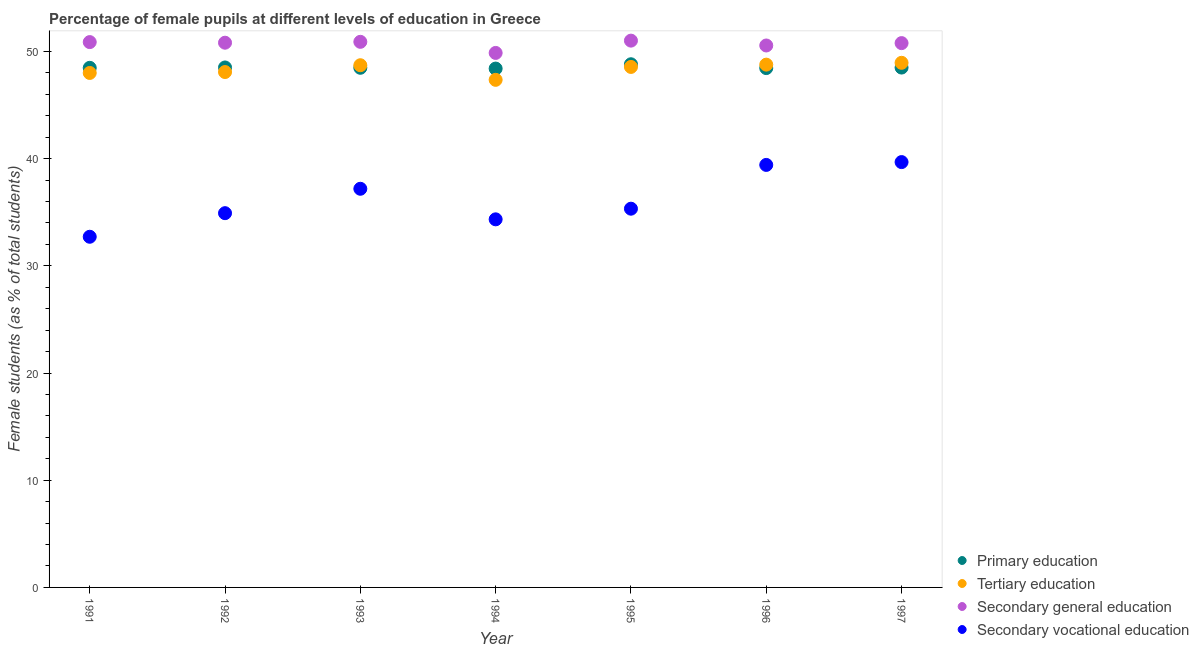Is the number of dotlines equal to the number of legend labels?
Provide a succinct answer. Yes. What is the percentage of female students in tertiary education in 1996?
Your response must be concise. 48.77. Across all years, what is the maximum percentage of female students in secondary vocational education?
Your answer should be very brief. 39.68. Across all years, what is the minimum percentage of female students in primary education?
Your response must be concise. 48.4. In which year was the percentage of female students in secondary education minimum?
Make the answer very short. 1994. What is the total percentage of female students in secondary education in the graph?
Offer a terse response. 354.77. What is the difference between the percentage of female students in secondary vocational education in 1996 and that in 1997?
Provide a succinct answer. -0.26. What is the difference between the percentage of female students in secondary vocational education in 1993 and the percentage of female students in secondary education in 1995?
Your answer should be very brief. -13.82. What is the average percentage of female students in primary education per year?
Keep it short and to the point. 48.51. In the year 1993, what is the difference between the percentage of female students in primary education and percentage of female students in secondary education?
Your answer should be very brief. -2.42. What is the ratio of the percentage of female students in tertiary education in 1995 to that in 1997?
Keep it short and to the point. 0.99. What is the difference between the highest and the second highest percentage of female students in secondary vocational education?
Your answer should be very brief. 0.26. What is the difference between the highest and the lowest percentage of female students in secondary education?
Offer a terse response. 1.15. Is the sum of the percentage of female students in tertiary education in 1992 and 1997 greater than the maximum percentage of female students in secondary vocational education across all years?
Ensure brevity in your answer.  Yes. Is it the case that in every year, the sum of the percentage of female students in primary education and percentage of female students in tertiary education is greater than the percentage of female students in secondary education?
Provide a succinct answer. Yes. Is the percentage of female students in primary education strictly greater than the percentage of female students in secondary vocational education over the years?
Keep it short and to the point. Yes. How many dotlines are there?
Your answer should be compact. 4. Are the values on the major ticks of Y-axis written in scientific E-notation?
Provide a short and direct response. No. Does the graph contain any zero values?
Offer a very short reply. No. Where does the legend appear in the graph?
Provide a succinct answer. Bottom right. How many legend labels are there?
Your answer should be very brief. 4. How are the legend labels stacked?
Ensure brevity in your answer.  Vertical. What is the title of the graph?
Keep it short and to the point. Percentage of female pupils at different levels of education in Greece. What is the label or title of the Y-axis?
Provide a short and direct response. Female students (as % of total students). What is the Female students (as % of total students) in Primary education in 1991?
Offer a very short reply. 48.47. What is the Female students (as % of total students) of Tertiary education in 1991?
Ensure brevity in your answer.  47.99. What is the Female students (as % of total students) of Secondary general education in 1991?
Your answer should be very brief. 50.87. What is the Female students (as % of total students) of Secondary vocational education in 1991?
Make the answer very short. 32.71. What is the Female students (as % of total students) in Primary education in 1992?
Offer a terse response. 48.5. What is the Female students (as % of total students) in Tertiary education in 1992?
Ensure brevity in your answer.  48.08. What is the Female students (as % of total students) in Secondary general education in 1992?
Your answer should be compact. 50.81. What is the Female students (as % of total students) in Secondary vocational education in 1992?
Give a very brief answer. 34.91. What is the Female students (as % of total students) of Primary education in 1993?
Your answer should be very brief. 48.47. What is the Female students (as % of total students) of Tertiary education in 1993?
Offer a terse response. 48.71. What is the Female students (as % of total students) of Secondary general education in 1993?
Give a very brief answer. 50.9. What is the Female students (as % of total students) of Secondary vocational education in 1993?
Offer a very short reply. 37.19. What is the Female students (as % of total students) in Primary education in 1994?
Offer a very short reply. 48.4. What is the Female students (as % of total students) of Tertiary education in 1994?
Your answer should be compact. 47.35. What is the Female students (as % of total students) of Secondary general education in 1994?
Offer a terse response. 49.86. What is the Female students (as % of total students) in Secondary vocational education in 1994?
Make the answer very short. 34.34. What is the Female students (as % of total students) of Primary education in 1995?
Give a very brief answer. 48.8. What is the Female students (as % of total students) in Tertiary education in 1995?
Your response must be concise. 48.55. What is the Female students (as % of total students) of Secondary general education in 1995?
Your answer should be very brief. 51.01. What is the Female students (as % of total students) in Secondary vocational education in 1995?
Make the answer very short. 35.33. What is the Female students (as % of total students) in Primary education in 1996?
Ensure brevity in your answer.  48.45. What is the Female students (as % of total students) of Tertiary education in 1996?
Offer a very short reply. 48.77. What is the Female students (as % of total students) in Secondary general education in 1996?
Ensure brevity in your answer.  50.55. What is the Female students (as % of total students) of Secondary vocational education in 1996?
Ensure brevity in your answer.  39.41. What is the Female students (as % of total students) in Primary education in 1997?
Your answer should be compact. 48.49. What is the Female students (as % of total students) of Tertiary education in 1997?
Keep it short and to the point. 48.94. What is the Female students (as % of total students) of Secondary general education in 1997?
Your response must be concise. 50.78. What is the Female students (as % of total students) of Secondary vocational education in 1997?
Provide a succinct answer. 39.68. Across all years, what is the maximum Female students (as % of total students) of Primary education?
Give a very brief answer. 48.8. Across all years, what is the maximum Female students (as % of total students) in Tertiary education?
Provide a short and direct response. 48.94. Across all years, what is the maximum Female students (as % of total students) in Secondary general education?
Offer a very short reply. 51.01. Across all years, what is the maximum Female students (as % of total students) of Secondary vocational education?
Offer a terse response. 39.68. Across all years, what is the minimum Female students (as % of total students) in Primary education?
Provide a short and direct response. 48.4. Across all years, what is the minimum Female students (as % of total students) of Tertiary education?
Provide a short and direct response. 47.35. Across all years, what is the minimum Female students (as % of total students) in Secondary general education?
Your response must be concise. 49.86. Across all years, what is the minimum Female students (as % of total students) of Secondary vocational education?
Offer a very short reply. 32.71. What is the total Female students (as % of total students) of Primary education in the graph?
Make the answer very short. 339.59. What is the total Female students (as % of total students) in Tertiary education in the graph?
Your answer should be very brief. 338.39. What is the total Female students (as % of total students) in Secondary general education in the graph?
Provide a succinct answer. 354.77. What is the total Female students (as % of total students) of Secondary vocational education in the graph?
Provide a succinct answer. 253.56. What is the difference between the Female students (as % of total students) of Primary education in 1991 and that in 1992?
Give a very brief answer. -0.03. What is the difference between the Female students (as % of total students) of Tertiary education in 1991 and that in 1992?
Provide a short and direct response. -0.09. What is the difference between the Female students (as % of total students) in Secondary general education in 1991 and that in 1992?
Offer a terse response. 0.06. What is the difference between the Female students (as % of total students) of Secondary vocational education in 1991 and that in 1992?
Your response must be concise. -2.2. What is the difference between the Female students (as % of total students) of Primary education in 1991 and that in 1993?
Give a very brief answer. -0. What is the difference between the Female students (as % of total students) in Tertiary education in 1991 and that in 1993?
Provide a succinct answer. -0.72. What is the difference between the Female students (as % of total students) in Secondary general education in 1991 and that in 1993?
Provide a short and direct response. -0.03. What is the difference between the Female students (as % of total students) in Secondary vocational education in 1991 and that in 1993?
Offer a terse response. -4.48. What is the difference between the Female students (as % of total students) in Primary education in 1991 and that in 1994?
Keep it short and to the point. 0.07. What is the difference between the Female students (as % of total students) in Tertiary education in 1991 and that in 1994?
Provide a succinct answer. 0.64. What is the difference between the Female students (as % of total students) in Secondary general education in 1991 and that in 1994?
Your answer should be compact. 1.01. What is the difference between the Female students (as % of total students) in Secondary vocational education in 1991 and that in 1994?
Keep it short and to the point. -1.63. What is the difference between the Female students (as % of total students) in Primary education in 1991 and that in 1995?
Offer a very short reply. -0.33. What is the difference between the Female students (as % of total students) of Tertiary education in 1991 and that in 1995?
Your answer should be very brief. -0.56. What is the difference between the Female students (as % of total students) of Secondary general education in 1991 and that in 1995?
Keep it short and to the point. -0.14. What is the difference between the Female students (as % of total students) in Secondary vocational education in 1991 and that in 1995?
Offer a terse response. -2.62. What is the difference between the Female students (as % of total students) of Primary education in 1991 and that in 1996?
Make the answer very short. 0.02. What is the difference between the Female students (as % of total students) of Tertiary education in 1991 and that in 1996?
Keep it short and to the point. -0.78. What is the difference between the Female students (as % of total students) in Secondary general education in 1991 and that in 1996?
Ensure brevity in your answer.  0.32. What is the difference between the Female students (as % of total students) in Secondary vocational education in 1991 and that in 1996?
Ensure brevity in your answer.  -6.7. What is the difference between the Female students (as % of total students) in Primary education in 1991 and that in 1997?
Offer a very short reply. -0.02. What is the difference between the Female students (as % of total students) in Tertiary education in 1991 and that in 1997?
Keep it short and to the point. -0.95. What is the difference between the Female students (as % of total students) in Secondary general education in 1991 and that in 1997?
Make the answer very short. 0.1. What is the difference between the Female students (as % of total students) in Secondary vocational education in 1991 and that in 1997?
Offer a terse response. -6.97. What is the difference between the Female students (as % of total students) of Primary education in 1992 and that in 1993?
Give a very brief answer. 0.03. What is the difference between the Female students (as % of total students) in Tertiary education in 1992 and that in 1993?
Provide a succinct answer. -0.64. What is the difference between the Female students (as % of total students) of Secondary general education in 1992 and that in 1993?
Provide a short and direct response. -0.08. What is the difference between the Female students (as % of total students) of Secondary vocational education in 1992 and that in 1993?
Your response must be concise. -2.28. What is the difference between the Female students (as % of total students) of Primary education in 1992 and that in 1994?
Your answer should be compact. 0.1. What is the difference between the Female students (as % of total students) of Tertiary education in 1992 and that in 1994?
Offer a very short reply. 0.73. What is the difference between the Female students (as % of total students) in Secondary general education in 1992 and that in 1994?
Give a very brief answer. 0.95. What is the difference between the Female students (as % of total students) in Secondary vocational education in 1992 and that in 1994?
Make the answer very short. 0.58. What is the difference between the Female students (as % of total students) in Primary education in 1992 and that in 1995?
Your answer should be compact. -0.3. What is the difference between the Female students (as % of total students) in Tertiary education in 1992 and that in 1995?
Offer a very short reply. -0.48. What is the difference between the Female students (as % of total students) in Secondary general education in 1992 and that in 1995?
Provide a short and direct response. -0.19. What is the difference between the Female students (as % of total students) in Secondary vocational education in 1992 and that in 1995?
Give a very brief answer. -0.42. What is the difference between the Female students (as % of total students) of Primary education in 1992 and that in 1996?
Provide a succinct answer. 0.06. What is the difference between the Female students (as % of total students) of Tertiary education in 1992 and that in 1996?
Your answer should be very brief. -0.69. What is the difference between the Female students (as % of total students) of Secondary general education in 1992 and that in 1996?
Your answer should be very brief. 0.26. What is the difference between the Female students (as % of total students) in Secondary vocational education in 1992 and that in 1996?
Ensure brevity in your answer.  -4.5. What is the difference between the Female students (as % of total students) in Primary education in 1992 and that in 1997?
Give a very brief answer. 0.01. What is the difference between the Female students (as % of total students) in Tertiary education in 1992 and that in 1997?
Your answer should be compact. -0.86. What is the difference between the Female students (as % of total students) in Secondary general education in 1992 and that in 1997?
Ensure brevity in your answer.  0.04. What is the difference between the Female students (as % of total students) of Secondary vocational education in 1992 and that in 1997?
Ensure brevity in your answer.  -4.76. What is the difference between the Female students (as % of total students) of Primary education in 1993 and that in 1994?
Ensure brevity in your answer.  0.07. What is the difference between the Female students (as % of total students) in Tertiary education in 1993 and that in 1994?
Give a very brief answer. 1.36. What is the difference between the Female students (as % of total students) in Secondary general education in 1993 and that in 1994?
Provide a short and direct response. 1.04. What is the difference between the Female students (as % of total students) of Secondary vocational education in 1993 and that in 1994?
Provide a succinct answer. 2.85. What is the difference between the Female students (as % of total students) of Primary education in 1993 and that in 1995?
Your response must be concise. -0.33. What is the difference between the Female students (as % of total students) in Tertiary education in 1993 and that in 1995?
Your response must be concise. 0.16. What is the difference between the Female students (as % of total students) of Secondary general education in 1993 and that in 1995?
Give a very brief answer. -0.11. What is the difference between the Female students (as % of total students) of Secondary vocational education in 1993 and that in 1995?
Your answer should be compact. 1.86. What is the difference between the Female students (as % of total students) in Primary education in 1993 and that in 1996?
Provide a short and direct response. 0.03. What is the difference between the Female students (as % of total students) of Tertiary education in 1993 and that in 1996?
Ensure brevity in your answer.  -0.06. What is the difference between the Female students (as % of total students) of Secondary general education in 1993 and that in 1996?
Ensure brevity in your answer.  0.34. What is the difference between the Female students (as % of total students) in Secondary vocational education in 1993 and that in 1996?
Ensure brevity in your answer.  -2.23. What is the difference between the Female students (as % of total students) in Primary education in 1993 and that in 1997?
Your answer should be compact. -0.02. What is the difference between the Female students (as % of total students) of Tertiary education in 1993 and that in 1997?
Offer a very short reply. -0.23. What is the difference between the Female students (as % of total students) of Secondary general education in 1993 and that in 1997?
Provide a short and direct response. 0.12. What is the difference between the Female students (as % of total students) of Secondary vocational education in 1993 and that in 1997?
Keep it short and to the point. -2.49. What is the difference between the Female students (as % of total students) of Primary education in 1994 and that in 1995?
Your response must be concise. -0.4. What is the difference between the Female students (as % of total students) of Tertiary education in 1994 and that in 1995?
Make the answer very short. -1.2. What is the difference between the Female students (as % of total students) in Secondary general education in 1994 and that in 1995?
Make the answer very short. -1.15. What is the difference between the Female students (as % of total students) in Secondary vocational education in 1994 and that in 1995?
Give a very brief answer. -0.99. What is the difference between the Female students (as % of total students) of Primary education in 1994 and that in 1996?
Make the answer very short. -0.05. What is the difference between the Female students (as % of total students) in Tertiary education in 1994 and that in 1996?
Keep it short and to the point. -1.42. What is the difference between the Female students (as % of total students) of Secondary general education in 1994 and that in 1996?
Your answer should be compact. -0.69. What is the difference between the Female students (as % of total students) of Secondary vocational education in 1994 and that in 1996?
Your answer should be compact. -5.08. What is the difference between the Female students (as % of total students) of Primary education in 1994 and that in 1997?
Keep it short and to the point. -0.09. What is the difference between the Female students (as % of total students) in Tertiary education in 1994 and that in 1997?
Provide a short and direct response. -1.59. What is the difference between the Female students (as % of total students) in Secondary general education in 1994 and that in 1997?
Offer a very short reply. -0.92. What is the difference between the Female students (as % of total students) in Secondary vocational education in 1994 and that in 1997?
Your answer should be very brief. -5.34. What is the difference between the Female students (as % of total students) of Primary education in 1995 and that in 1996?
Your answer should be compact. 0.36. What is the difference between the Female students (as % of total students) in Tertiary education in 1995 and that in 1996?
Provide a succinct answer. -0.21. What is the difference between the Female students (as % of total students) of Secondary general education in 1995 and that in 1996?
Provide a succinct answer. 0.45. What is the difference between the Female students (as % of total students) of Secondary vocational education in 1995 and that in 1996?
Provide a succinct answer. -4.08. What is the difference between the Female students (as % of total students) in Primary education in 1995 and that in 1997?
Your response must be concise. 0.31. What is the difference between the Female students (as % of total students) in Tertiary education in 1995 and that in 1997?
Provide a succinct answer. -0.38. What is the difference between the Female students (as % of total students) of Secondary general education in 1995 and that in 1997?
Provide a succinct answer. 0.23. What is the difference between the Female students (as % of total students) in Secondary vocational education in 1995 and that in 1997?
Provide a short and direct response. -4.35. What is the difference between the Female students (as % of total students) of Primary education in 1996 and that in 1997?
Ensure brevity in your answer.  -0.05. What is the difference between the Female students (as % of total students) of Tertiary education in 1996 and that in 1997?
Keep it short and to the point. -0.17. What is the difference between the Female students (as % of total students) in Secondary general education in 1996 and that in 1997?
Offer a terse response. -0.22. What is the difference between the Female students (as % of total students) of Secondary vocational education in 1996 and that in 1997?
Provide a succinct answer. -0.26. What is the difference between the Female students (as % of total students) of Primary education in 1991 and the Female students (as % of total students) of Tertiary education in 1992?
Give a very brief answer. 0.39. What is the difference between the Female students (as % of total students) of Primary education in 1991 and the Female students (as % of total students) of Secondary general education in 1992?
Your response must be concise. -2.34. What is the difference between the Female students (as % of total students) of Primary education in 1991 and the Female students (as % of total students) of Secondary vocational education in 1992?
Give a very brief answer. 13.56. What is the difference between the Female students (as % of total students) in Tertiary education in 1991 and the Female students (as % of total students) in Secondary general education in 1992?
Your answer should be compact. -2.82. What is the difference between the Female students (as % of total students) of Tertiary education in 1991 and the Female students (as % of total students) of Secondary vocational education in 1992?
Offer a very short reply. 13.08. What is the difference between the Female students (as % of total students) of Secondary general education in 1991 and the Female students (as % of total students) of Secondary vocational education in 1992?
Your answer should be compact. 15.96. What is the difference between the Female students (as % of total students) of Primary education in 1991 and the Female students (as % of total students) of Tertiary education in 1993?
Give a very brief answer. -0.24. What is the difference between the Female students (as % of total students) in Primary education in 1991 and the Female students (as % of total students) in Secondary general education in 1993?
Give a very brief answer. -2.43. What is the difference between the Female students (as % of total students) in Primary education in 1991 and the Female students (as % of total students) in Secondary vocational education in 1993?
Offer a terse response. 11.28. What is the difference between the Female students (as % of total students) in Tertiary education in 1991 and the Female students (as % of total students) in Secondary general education in 1993?
Make the answer very short. -2.9. What is the difference between the Female students (as % of total students) of Tertiary education in 1991 and the Female students (as % of total students) of Secondary vocational education in 1993?
Your response must be concise. 10.8. What is the difference between the Female students (as % of total students) in Secondary general education in 1991 and the Female students (as % of total students) in Secondary vocational education in 1993?
Ensure brevity in your answer.  13.68. What is the difference between the Female students (as % of total students) in Primary education in 1991 and the Female students (as % of total students) in Tertiary education in 1994?
Provide a short and direct response. 1.12. What is the difference between the Female students (as % of total students) in Primary education in 1991 and the Female students (as % of total students) in Secondary general education in 1994?
Ensure brevity in your answer.  -1.39. What is the difference between the Female students (as % of total students) in Primary education in 1991 and the Female students (as % of total students) in Secondary vocational education in 1994?
Your response must be concise. 14.13. What is the difference between the Female students (as % of total students) in Tertiary education in 1991 and the Female students (as % of total students) in Secondary general education in 1994?
Keep it short and to the point. -1.87. What is the difference between the Female students (as % of total students) of Tertiary education in 1991 and the Female students (as % of total students) of Secondary vocational education in 1994?
Offer a terse response. 13.66. What is the difference between the Female students (as % of total students) in Secondary general education in 1991 and the Female students (as % of total students) in Secondary vocational education in 1994?
Give a very brief answer. 16.53. What is the difference between the Female students (as % of total students) in Primary education in 1991 and the Female students (as % of total students) in Tertiary education in 1995?
Give a very brief answer. -0.08. What is the difference between the Female students (as % of total students) in Primary education in 1991 and the Female students (as % of total students) in Secondary general education in 1995?
Keep it short and to the point. -2.54. What is the difference between the Female students (as % of total students) of Primary education in 1991 and the Female students (as % of total students) of Secondary vocational education in 1995?
Provide a succinct answer. 13.14. What is the difference between the Female students (as % of total students) of Tertiary education in 1991 and the Female students (as % of total students) of Secondary general education in 1995?
Your answer should be compact. -3.01. What is the difference between the Female students (as % of total students) in Tertiary education in 1991 and the Female students (as % of total students) in Secondary vocational education in 1995?
Provide a succinct answer. 12.66. What is the difference between the Female students (as % of total students) in Secondary general education in 1991 and the Female students (as % of total students) in Secondary vocational education in 1995?
Your response must be concise. 15.54. What is the difference between the Female students (as % of total students) of Primary education in 1991 and the Female students (as % of total students) of Tertiary education in 1996?
Keep it short and to the point. -0.3. What is the difference between the Female students (as % of total students) of Primary education in 1991 and the Female students (as % of total students) of Secondary general education in 1996?
Provide a succinct answer. -2.08. What is the difference between the Female students (as % of total students) of Primary education in 1991 and the Female students (as % of total students) of Secondary vocational education in 1996?
Provide a short and direct response. 9.06. What is the difference between the Female students (as % of total students) in Tertiary education in 1991 and the Female students (as % of total students) in Secondary general education in 1996?
Your answer should be compact. -2.56. What is the difference between the Female students (as % of total students) of Tertiary education in 1991 and the Female students (as % of total students) of Secondary vocational education in 1996?
Offer a very short reply. 8.58. What is the difference between the Female students (as % of total students) in Secondary general education in 1991 and the Female students (as % of total students) in Secondary vocational education in 1996?
Your response must be concise. 11.46. What is the difference between the Female students (as % of total students) in Primary education in 1991 and the Female students (as % of total students) in Tertiary education in 1997?
Your response must be concise. -0.47. What is the difference between the Female students (as % of total students) of Primary education in 1991 and the Female students (as % of total students) of Secondary general education in 1997?
Your answer should be very brief. -2.31. What is the difference between the Female students (as % of total students) of Primary education in 1991 and the Female students (as % of total students) of Secondary vocational education in 1997?
Give a very brief answer. 8.79. What is the difference between the Female students (as % of total students) in Tertiary education in 1991 and the Female students (as % of total students) in Secondary general education in 1997?
Provide a short and direct response. -2.78. What is the difference between the Female students (as % of total students) of Tertiary education in 1991 and the Female students (as % of total students) of Secondary vocational education in 1997?
Provide a succinct answer. 8.32. What is the difference between the Female students (as % of total students) of Secondary general education in 1991 and the Female students (as % of total students) of Secondary vocational education in 1997?
Ensure brevity in your answer.  11.19. What is the difference between the Female students (as % of total students) of Primary education in 1992 and the Female students (as % of total students) of Tertiary education in 1993?
Your answer should be compact. -0.21. What is the difference between the Female students (as % of total students) in Primary education in 1992 and the Female students (as % of total students) in Secondary general education in 1993?
Your answer should be compact. -2.39. What is the difference between the Female students (as % of total students) of Primary education in 1992 and the Female students (as % of total students) of Secondary vocational education in 1993?
Provide a succinct answer. 11.32. What is the difference between the Female students (as % of total students) of Tertiary education in 1992 and the Female students (as % of total students) of Secondary general education in 1993?
Keep it short and to the point. -2.82. What is the difference between the Female students (as % of total students) in Tertiary education in 1992 and the Female students (as % of total students) in Secondary vocational education in 1993?
Provide a succinct answer. 10.89. What is the difference between the Female students (as % of total students) of Secondary general education in 1992 and the Female students (as % of total students) of Secondary vocational education in 1993?
Your answer should be compact. 13.63. What is the difference between the Female students (as % of total students) of Primary education in 1992 and the Female students (as % of total students) of Tertiary education in 1994?
Your answer should be compact. 1.15. What is the difference between the Female students (as % of total students) of Primary education in 1992 and the Female students (as % of total students) of Secondary general education in 1994?
Offer a very short reply. -1.36. What is the difference between the Female students (as % of total students) in Primary education in 1992 and the Female students (as % of total students) in Secondary vocational education in 1994?
Provide a short and direct response. 14.17. What is the difference between the Female students (as % of total students) of Tertiary education in 1992 and the Female students (as % of total students) of Secondary general education in 1994?
Your response must be concise. -1.78. What is the difference between the Female students (as % of total students) of Tertiary education in 1992 and the Female students (as % of total students) of Secondary vocational education in 1994?
Keep it short and to the point. 13.74. What is the difference between the Female students (as % of total students) of Secondary general education in 1992 and the Female students (as % of total students) of Secondary vocational education in 1994?
Your answer should be compact. 16.48. What is the difference between the Female students (as % of total students) of Primary education in 1992 and the Female students (as % of total students) of Tertiary education in 1995?
Provide a short and direct response. -0.05. What is the difference between the Female students (as % of total students) in Primary education in 1992 and the Female students (as % of total students) in Secondary general education in 1995?
Your response must be concise. -2.5. What is the difference between the Female students (as % of total students) of Primary education in 1992 and the Female students (as % of total students) of Secondary vocational education in 1995?
Provide a short and direct response. 13.17. What is the difference between the Female students (as % of total students) in Tertiary education in 1992 and the Female students (as % of total students) in Secondary general education in 1995?
Offer a terse response. -2.93. What is the difference between the Female students (as % of total students) of Tertiary education in 1992 and the Female students (as % of total students) of Secondary vocational education in 1995?
Your response must be concise. 12.75. What is the difference between the Female students (as % of total students) of Secondary general education in 1992 and the Female students (as % of total students) of Secondary vocational education in 1995?
Keep it short and to the point. 15.48. What is the difference between the Female students (as % of total students) in Primary education in 1992 and the Female students (as % of total students) in Tertiary education in 1996?
Keep it short and to the point. -0.26. What is the difference between the Female students (as % of total students) in Primary education in 1992 and the Female students (as % of total students) in Secondary general education in 1996?
Ensure brevity in your answer.  -2.05. What is the difference between the Female students (as % of total students) of Primary education in 1992 and the Female students (as % of total students) of Secondary vocational education in 1996?
Ensure brevity in your answer.  9.09. What is the difference between the Female students (as % of total students) of Tertiary education in 1992 and the Female students (as % of total students) of Secondary general education in 1996?
Your answer should be very brief. -2.48. What is the difference between the Female students (as % of total students) of Tertiary education in 1992 and the Female students (as % of total students) of Secondary vocational education in 1996?
Your answer should be very brief. 8.66. What is the difference between the Female students (as % of total students) of Secondary general education in 1992 and the Female students (as % of total students) of Secondary vocational education in 1996?
Give a very brief answer. 11.4. What is the difference between the Female students (as % of total students) of Primary education in 1992 and the Female students (as % of total students) of Tertiary education in 1997?
Provide a succinct answer. -0.43. What is the difference between the Female students (as % of total students) in Primary education in 1992 and the Female students (as % of total students) in Secondary general education in 1997?
Give a very brief answer. -2.27. What is the difference between the Female students (as % of total students) of Primary education in 1992 and the Female students (as % of total students) of Secondary vocational education in 1997?
Offer a terse response. 8.83. What is the difference between the Female students (as % of total students) in Tertiary education in 1992 and the Female students (as % of total students) in Secondary general education in 1997?
Provide a succinct answer. -2.7. What is the difference between the Female students (as % of total students) in Tertiary education in 1992 and the Female students (as % of total students) in Secondary vocational education in 1997?
Offer a very short reply. 8.4. What is the difference between the Female students (as % of total students) of Secondary general education in 1992 and the Female students (as % of total students) of Secondary vocational education in 1997?
Give a very brief answer. 11.14. What is the difference between the Female students (as % of total students) of Primary education in 1993 and the Female students (as % of total students) of Tertiary education in 1994?
Keep it short and to the point. 1.12. What is the difference between the Female students (as % of total students) of Primary education in 1993 and the Female students (as % of total students) of Secondary general education in 1994?
Provide a short and direct response. -1.39. What is the difference between the Female students (as % of total students) in Primary education in 1993 and the Female students (as % of total students) in Secondary vocational education in 1994?
Provide a succinct answer. 14.14. What is the difference between the Female students (as % of total students) of Tertiary education in 1993 and the Female students (as % of total students) of Secondary general education in 1994?
Your answer should be very brief. -1.15. What is the difference between the Female students (as % of total students) of Tertiary education in 1993 and the Female students (as % of total students) of Secondary vocational education in 1994?
Ensure brevity in your answer.  14.38. What is the difference between the Female students (as % of total students) in Secondary general education in 1993 and the Female students (as % of total students) in Secondary vocational education in 1994?
Offer a very short reply. 16.56. What is the difference between the Female students (as % of total students) of Primary education in 1993 and the Female students (as % of total students) of Tertiary education in 1995?
Keep it short and to the point. -0.08. What is the difference between the Female students (as % of total students) of Primary education in 1993 and the Female students (as % of total students) of Secondary general education in 1995?
Your answer should be compact. -2.53. What is the difference between the Female students (as % of total students) in Primary education in 1993 and the Female students (as % of total students) in Secondary vocational education in 1995?
Offer a very short reply. 13.14. What is the difference between the Female students (as % of total students) of Tertiary education in 1993 and the Female students (as % of total students) of Secondary general education in 1995?
Offer a terse response. -2.29. What is the difference between the Female students (as % of total students) in Tertiary education in 1993 and the Female students (as % of total students) in Secondary vocational education in 1995?
Give a very brief answer. 13.38. What is the difference between the Female students (as % of total students) of Secondary general education in 1993 and the Female students (as % of total students) of Secondary vocational education in 1995?
Ensure brevity in your answer.  15.57. What is the difference between the Female students (as % of total students) in Primary education in 1993 and the Female students (as % of total students) in Tertiary education in 1996?
Make the answer very short. -0.29. What is the difference between the Female students (as % of total students) of Primary education in 1993 and the Female students (as % of total students) of Secondary general education in 1996?
Ensure brevity in your answer.  -2.08. What is the difference between the Female students (as % of total students) of Primary education in 1993 and the Female students (as % of total students) of Secondary vocational education in 1996?
Offer a very short reply. 9.06. What is the difference between the Female students (as % of total students) of Tertiary education in 1993 and the Female students (as % of total students) of Secondary general education in 1996?
Offer a very short reply. -1.84. What is the difference between the Female students (as % of total students) in Tertiary education in 1993 and the Female students (as % of total students) in Secondary vocational education in 1996?
Make the answer very short. 9.3. What is the difference between the Female students (as % of total students) of Secondary general education in 1993 and the Female students (as % of total students) of Secondary vocational education in 1996?
Your response must be concise. 11.48. What is the difference between the Female students (as % of total students) in Primary education in 1993 and the Female students (as % of total students) in Tertiary education in 1997?
Give a very brief answer. -0.46. What is the difference between the Female students (as % of total students) of Primary education in 1993 and the Female students (as % of total students) of Secondary general education in 1997?
Provide a succinct answer. -2.3. What is the difference between the Female students (as % of total students) in Primary education in 1993 and the Female students (as % of total students) in Secondary vocational education in 1997?
Your response must be concise. 8.8. What is the difference between the Female students (as % of total students) of Tertiary education in 1993 and the Female students (as % of total students) of Secondary general education in 1997?
Offer a very short reply. -2.06. What is the difference between the Female students (as % of total students) in Tertiary education in 1993 and the Female students (as % of total students) in Secondary vocational education in 1997?
Offer a terse response. 9.04. What is the difference between the Female students (as % of total students) in Secondary general education in 1993 and the Female students (as % of total students) in Secondary vocational education in 1997?
Your response must be concise. 11.22. What is the difference between the Female students (as % of total students) in Primary education in 1994 and the Female students (as % of total students) in Tertiary education in 1995?
Keep it short and to the point. -0.15. What is the difference between the Female students (as % of total students) of Primary education in 1994 and the Female students (as % of total students) of Secondary general education in 1995?
Offer a terse response. -2.61. What is the difference between the Female students (as % of total students) in Primary education in 1994 and the Female students (as % of total students) in Secondary vocational education in 1995?
Offer a terse response. 13.07. What is the difference between the Female students (as % of total students) in Tertiary education in 1994 and the Female students (as % of total students) in Secondary general education in 1995?
Make the answer very short. -3.66. What is the difference between the Female students (as % of total students) in Tertiary education in 1994 and the Female students (as % of total students) in Secondary vocational education in 1995?
Your response must be concise. 12.02. What is the difference between the Female students (as % of total students) of Secondary general education in 1994 and the Female students (as % of total students) of Secondary vocational education in 1995?
Your answer should be compact. 14.53. What is the difference between the Female students (as % of total students) of Primary education in 1994 and the Female students (as % of total students) of Tertiary education in 1996?
Your response must be concise. -0.37. What is the difference between the Female students (as % of total students) in Primary education in 1994 and the Female students (as % of total students) in Secondary general education in 1996?
Make the answer very short. -2.15. What is the difference between the Female students (as % of total students) in Primary education in 1994 and the Female students (as % of total students) in Secondary vocational education in 1996?
Keep it short and to the point. 8.99. What is the difference between the Female students (as % of total students) in Tertiary education in 1994 and the Female students (as % of total students) in Secondary general education in 1996?
Offer a terse response. -3.2. What is the difference between the Female students (as % of total students) of Tertiary education in 1994 and the Female students (as % of total students) of Secondary vocational education in 1996?
Give a very brief answer. 7.94. What is the difference between the Female students (as % of total students) in Secondary general education in 1994 and the Female students (as % of total students) in Secondary vocational education in 1996?
Offer a terse response. 10.45. What is the difference between the Female students (as % of total students) in Primary education in 1994 and the Female students (as % of total students) in Tertiary education in 1997?
Your answer should be very brief. -0.54. What is the difference between the Female students (as % of total students) in Primary education in 1994 and the Female students (as % of total students) in Secondary general education in 1997?
Keep it short and to the point. -2.37. What is the difference between the Female students (as % of total students) of Primary education in 1994 and the Female students (as % of total students) of Secondary vocational education in 1997?
Offer a very short reply. 8.72. What is the difference between the Female students (as % of total students) of Tertiary education in 1994 and the Female students (as % of total students) of Secondary general education in 1997?
Provide a succinct answer. -3.43. What is the difference between the Female students (as % of total students) in Tertiary education in 1994 and the Female students (as % of total students) in Secondary vocational education in 1997?
Your answer should be compact. 7.67. What is the difference between the Female students (as % of total students) of Secondary general education in 1994 and the Female students (as % of total students) of Secondary vocational education in 1997?
Make the answer very short. 10.18. What is the difference between the Female students (as % of total students) in Primary education in 1995 and the Female students (as % of total students) in Tertiary education in 1996?
Your answer should be very brief. 0.04. What is the difference between the Female students (as % of total students) in Primary education in 1995 and the Female students (as % of total students) in Secondary general education in 1996?
Your answer should be compact. -1.75. What is the difference between the Female students (as % of total students) in Primary education in 1995 and the Female students (as % of total students) in Secondary vocational education in 1996?
Give a very brief answer. 9.39. What is the difference between the Female students (as % of total students) in Tertiary education in 1995 and the Female students (as % of total students) in Secondary general education in 1996?
Provide a short and direct response. -2. What is the difference between the Female students (as % of total students) of Tertiary education in 1995 and the Female students (as % of total students) of Secondary vocational education in 1996?
Keep it short and to the point. 9.14. What is the difference between the Female students (as % of total students) of Secondary general education in 1995 and the Female students (as % of total students) of Secondary vocational education in 1996?
Offer a terse response. 11.59. What is the difference between the Female students (as % of total students) of Primary education in 1995 and the Female students (as % of total students) of Tertiary education in 1997?
Your response must be concise. -0.13. What is the difference between the Female students (as % of total students) in Primary education in 1995 and the Female students (as % of total students) in Secondary general education in 1997?
Your response must be concise. -1.97. What is the difference between the Female students (as % of total students) of Primary education in 1995 and the Female students (as % of total students) of Secondary vocational education in 1997?
Your response must be concise. 9.13. What is the difference between the Female students (as % of total students) in Tertiary education in 1995 and the Female students (as % of total students) in Secondary general education in 1997?
Your response must be concise. -2.22. What is the difference between the Female students (as % of total students) of Tertiary education in 1995 and the Female students (as % of total students) of Secondary vocational education in 1997?
Offer a very short reply. 8.88. What is the difference between the Female students (as % of total students) of Secondary general education in 1995 and the Female students (as % of total students) of Secondary vocational education in 1997?
Provide a short and direct response. 11.33. What is the difference between the Female students (as % of total students) of Primary education in 1996 and the Female students (as % of total students) of Tertiary education in 1997?
Offer a very short reply. -0.49. What is the difference between the Female students (as % of total students) of Primary education in 1996 and the Female students (as % of total students) of Secondary general education in 1997?
Keep it short and to the point. -2.33. What is the difference between the Female students (as % of total students) of Primary education in 1996 and the Female students (as % of total students) of Secondary vocational education in 1997?
Make the answer very short. 8.77. What is the difference between the Female students (as % of total students) of Tertiary education in 1996 and the Female students (as % of total students) of Secondary general education in 1997?
Offer a very short reply. -2.01. What is the difference between the Female students (as % of total students) in Tertiary education in 1996 and the Female students (as % of total students) in Secondary vocational education in 1997?
Make the answer very short. 9.09. What is the difference between the Female students (as % of total students) of Secondary general education in 1996 and the Female students (as % of total students) of Secondary vocational education in 1997?
Keep it short and to the point. 10.88. What is the average Female students (as % of total students) of Primary education per year?
Your answer should be very brief. 48.51. What is the average Female students (as % of total students) in Tertiary education per year?
Your answer should be very brief. 48.34. What is the average Female students (as % of total students) of Secondary general education per year?
Your answer should be compact. 50.68. What is the average Female students (as % of total students) in Secondary vocational education per year?
Ensure brevity in your answer.  36.22. In the year 1991, what is the difference between the Female students (as % of total students) of Primary education and Female students (as % of total students) of Tertiary education?
Your answer should be compact. 0.48. In the year 1991, what is the difference between the Female students (as % of total students) of Primary education and Female students (as % of total students) of Secondary general education?
Your answer should be very brief. -2.4. In the year 1991, what is the difference between the Female students (as % of total students) of Primary education and Female students (as % of total students) of Secondary vocational education?
Keep it short and to the point. 15.76. In the year 1991, what is the difference between the Female students (as % of total students) in Tertiary education and Female students (as % of total students) in Secondary general education?
Offer a terse response. -2.88. In the year 1991, what is the difference between the Female students (as % of total students) in Tertiary education and Female students (as % of total students) in Secondary vocational education?
Provide a short and direct response. 15.28. In the year 1991, what is the difference between the Female students (as % of total students) of Secondary general education and Female students (as % of total students) of Secondary vocational education?
Offer a terse response. 18.16. In the year 1992, what is the difference between the Female students (as % of total students) in Primary education and Female students (as % of total students) in Tertiary education?
Give a very brief answer. 0.43. In the year 1992, what is the difference between the Female students (as % of total students) in Primary education and Female students (as % of total students) in Secondary general education?
Make the answer very short. -2.31. In the year 1992, what is the difference between the Female students (as % of total students) in Primary education and Female students (as % of total students) in Secondary vocational education?
Ensure brevity in your answer.  13.59. In the year 1992, what is the difference between the Female students (as % of total students) of Tertiary education and Female students (as % of total students) of Secondary general education?
Offer a terse response. -2.74. In the year 1992, what is the difference between the Female students (as % of total students) of Tertiary education and Female students (as % of total students) of Secondary vocational education?
Provide a short and direct response. 13.17. In the year 1992, what is the difference between the Female students (as % of total students) in Secondary general education and Female students (as % of total students) in Secondary vocational education?
Provide a short and direct response. 15.9. In the year 1993, what is the difference between the Female students (as % of total students) of Primary education and Female students (as % of total students) of Tertiary education?
Make the answer very short. -0.24. In the year 1993, what is the difference between the Female students (as % of total students) in Primary education and Female students (as % of total students) in Secondary general education?
Offer a very short reply. -2.42. In the year 1993, what is the difference between the Female students (as % of total students) in Primary education and Female students (as % of total students) in Secondary vocational education?
Provide a succinct answer. 11.29. In the year 1993, what is the difference between the Female students (as % of total students) of Tertiary education and Female students (as % of total students) of Secondary general education?
Provide a succinct answer. -2.18. In the year 1993, what is the difference between the Female students (as % of total students) in Tertiary education and Female students (as % of total students) in Secondary vocational education?
Make the answer very short. 11.52. In the year 1993, what is the difference between the Female students (as % of total students) in Secondary general education and Female students (as % of total students) in Secondary vocational education?
Offer a terse response. 13.71. In the year 1994, what is the difference between the Female students (as % of total students) of Primary education and Female students (as % of total students) of Tertiary education?
Provide a succinct answer. 1.05. In the year 1994, what is the difference between the Female students (as % of total students) of Primary education and Female students (as % of total students) of Secondary general education?
Keep it short and to the point. -1.46. In the year 1994, what is the difference between the Female students (as % of total students) of Primary education and Female students (as % of total students) of Secondary vocational education?
Make the answer very short. 14.06. In the year 1994, what is the difference between the Female students (as % of total students) of Tertiary education and Female students (as % of total students) of Secondary general education?
Keep it short and to the point. -2.51. In the year 1994, what is the difference between the Female students (as % of total students) in Tertiary education and Female students (as % of total students) in Secondary vocational education?
Make the answer very short. 13.01. In the year 1994, what is the difference between the Female students (as % of total students) of Secondary general education and Female students (as % of total students) of Secondary vocational education?
Provide a succinct answer. 15.52. In the year 1995, what is the difference between the Female students (as % of total students) of Primary education and Female students (as % of total students) of Tertiary education?
Your response must be concise. 0.25. In the year 1995, what is the difference between the Female students (as % of total students) in Primary education and Female students (as % of total students) in Secondary general education?
Make the answer very short. -2.2. In the year 1995, what is the difference between the Female students (as % of total students) in Primary education and Female students (as % of total students) in Secondary vocational education?
Your response must be concise. 13.47. In the year 1995, what is the difference between the Female students (as % of total students) in Tertiary education and Female students (as % of total students) in Secondary general education?
Provide a short and direct response. -2.45. In the year 1995, what is the difference between the Female students (as % of total students) in Tertiary education and Female students (as % of total students) in Secondary vocational education?
Provide a short and direct response. 13.22. In the year 1995, what is the difference between the Female students (as % of total students) in Secondary general education and Female students (as % of total students) in Secondary vocational education?
Offer a terse response. 15.68. In the year 1996, what is the difference between the Female students (as % of total students) of Primary education and Female students (as % of total students) of Tertiary education?
Provide a succinct answer. -0.32. In the year 1996, what is the difference between the Female students (as % of total students) of Primary education and Female students (as % of total students) of Secondary general education?
Keep it short and to the point. -2.11. In the year 1996, what is the difference between the Female students (as % of total students) of Primary education and Female students (as % of total students) of Secondary vocational education?
Your answer should be compact. 9.03. In the year 1996, what is the difference between the Female students (as % of total students) of Tertiary education and Female students (as % of total students) of Secondary general education?
Offer a terse response. -1.79. In the year 1996, what is the difference between the Female students (as % of total students) in Tertiary education and Female students (as % of total students) in Secondary vocational education?
Make the answer very short. 9.35. In the year 1996, what is the difference between the Female students (as % of total students) of Secondary general education and Female students (as % of total students) of Secondary vocational education?
Your answer should be compact. 11.14. In the year 1997, what is the difference between the Female students (as % of total students) of Primary education and Female students (as % of total students) of Tertiary education?
Your answer should be compact. -0.44. In the year 1997, what is the difference between the Female students (as % of total students) of Primary education and Female students (as % of total students) of Secondary general education?
Give a very brief answer. -2.28. In the year 1997, what is the difference between the Female students (as % of total students) of Primary education and Female students (as % of total students) of Secondary vocational education?
Provide a succinct answer. 8.82. In the year 1997, what is the difference between the Female students (as % of total students) in Tertiary education and Female students (as % of total students) in Secondary general education?
Offer a terse response. -1.84. In the year 1997, what is the difference between the Female students (as % of total students) in Tertiary education and Female students (as % of total students) in Secondary vocational education?
Make the answer very short. 9.26. In the year 1997, what is the difference between the Female students (as % of total students) of Secondary general education and Female students (as % of total students) of Secondary vocational education?
Your answer should be very brief. 11.1. What is the ratio of the Female students (as % of total students) of Tertiary education in 1991 to that in 1992?
Offer a very short reply. 1. What is the ratio of the Female students (as % of total students) in Secondary general education in 1991 to that in 1992?
Make the answer very short. 1. What is the ratio of the Female students (as % of total students) in Secondary vocational education in 1991 to that in 1992?
Give a very brief answer. 0.94. What is the ratio of the Female students (as % of total students) in Tertiary education in 1991 to that in 1993?
Your response must be concise. 0.99. What is the ratio of the Female students (as % of total students) of Secondary vocational education in 1991 to that in 1993?
Make the answer very short. 0.88. What is the ratio of the Female students (as % of total students) in Tertiary education in 1991 to that in 1994?
Keep it short and to the point. 1.01. What is the ratio of the Female students (as % of total students) in Secondary general education in 1991 to that in 1994?
Provide a short and direct response. 1.02. What is the ratio of the Female students (as % of total students) of Secondary vocational education in 1991 to that in 1994?
Your response must be concise. 0.95. What is the ratio of the Female students (as % of total students) in Primary education in 1991 to that in 1995?
Offer a terse response. 0.99. What is the ratio of the Female students (as % of total students) of Tertiary education in 1991 to that in 1995?
Ensure brevity in your answer.  0.99. What is the ratio of the Female students (as % of total students) in Secondary general education in 1991 to that in 1995?
Your answer should be very brief. 1. What is the ratio of the Female students (as % of total students) in Secondary vocational education in 1991 to that in 1995?
Give a very brief answer. 0.93. What is the ratio of the Female students (as % of total students) in Tertiary education in 1991 to that in 1996?
Your response must be concise. 0.98. What is the ratio of the Female students (as % of total students) in Secondary vocational education in 1991 to that in 1996?
Your answer should be compact. 0.83. What is the ratio of the Female students (as % of total students) in Primary education in 1991 to that in 1997?
Offer a very short reply. 1. What is the ratio of the Female students (as % of total students) in Tertiary education in 1991 to that in 1997?
Your answer should be compact. 0.98. What is the ratio of the Female students (as % of total students) in Secondary vocational education in 1991 to that in 1997?
Make the answer very short. 0.82. What is the ratio of the Female students (as % of total students) in Primary education in 1992 to that in 1993?
Give a very brief answer. 1. What is the ratio of the Female students (as % of total students) of Tertiary education in 1992 to that in 1993?
Offer a terse response. 0.99. What is the ratio of the Female students (as % of total students) in Secondary general education in 1992 to that in 1993?
Provide a short and direct response. 1. What is the ratio of the Female students (as % of total students) in Secondary vocational education in 1992 to that in 1993?
Ensure brevity in your answer.  0.94. What is the ratio of the Female students (as % of total students) of Tertiary education in 1992 to that in 1994?
Your response must be concise. 1.02. What is the ratio of the Female students (as % of total students) of Secondary general education in 1992 to that in 1994?
Make the answer very short. 1.02. What is the ratio of the Female students (as % of total students) of Secondary vocational education in 1992 to that in 1994?
Ensure brevity in your answer.  1.02. What is the ratio of the Female students (as % of total students) in Tertiary education in 1992 to that in 1995?
Provide a short and direct response. 0.99. What is the ratio of the Female students (as % of total students) of Secondary general education in 1992 to that in 1995?
Provide a short and direct response. 1. What is the ratio of the Female students (as % of total students) of Secondary vocational education in 1992 to that in 1995?
Make the answer very short. 0.99. What is the ratio of the Female students (as % of total students) in Tertiary education in 1992 to that in 1996?
Your answer should be compact. 0.99. What is the ratio of the Female students (as % of total students) of Secondary vocational education in 1992 to that in 1996?
Keep it short and to the point. 0.89. What is the ratio of the Female students (as % of total students) of Primary education in 1992 to that in 1997?
Ensure brevity in your answer.  1. What is the ratio of the Female students (as % of total students) of Tertiary education in 1992 to that in 1997?
Your answer should be compact. 0.98. What is the ratio of the Female students (as % of total students) in Secondary vocational education in 1992 to that in 1997?
Keep it short and to the point. 0.88. What is the ratio of the Female students (as % of total students) of Tertiary education in 1993 to that in 1994?
Your answer should be compact. 1.03. What is the ratio of the Female students (as % of total students) in Secondary general education in 1993 to that in 1994?
Make the answer very short. 1.02. What is the ratio of the Female students (as % of total students) in Secondary vocational education in 1993 to that in 1994?
Your answer should be compact. 1.08. What is the ratio of the Female students (as % of total students) of Primary education in 1993 to that in 1995?
Provide a succinct answer. 0.99. What is the ratio of the Female students (as % of total students) of Tertiary education in 1993 to that in 1995?
Give a very brief answer. 1. What is the ratio of the Female students (as % of total students) of Secondary vocational education in 1993 to that in 1995?
Offer a terse response. 1.05. What is the ratio of the Female students (as % of total students) in Primary education in 1993 to that in 1996?
Your answer should be compact. 1. What is the ratio of the Female students (as % of total students) of Secondary general education in 1993 to that in 1996?
Provide a short and direct response. 1.01. What is the ratio of the Female students (as % of total students) in Secondary vocational education in 1993 to that in 1996?
Keep it short and to the point. 0.94. What is the ratio of the Female students (as % of total students) of Primary education in 1993 to that in 1997?
Offer a terse response. 1. What is the ratio of the Female students (as % of total students) of Secondary vocational education in 1993 to that in 1997?
Ensure brevity in your answer.  0.94. What is the ratio of the Female students (as % of total students) of Primary education in 1994 to that in 1995?
Provide a short and direct response. 0.99. What is the ratio of the Female students (as % of total students) in Tertiary education in 1994 to that in 1995?
Offer a terse response. 0.98. What is the ratio of the Female students (as % of total students) in Secondary general education in 1994 to that in 1995?
Your answer should be very brief. 0.98. What is the ratio of the Female students (as % of total students) in Secondary vocational education in 1994 to that in 1995?
Keep it short and to the point. 0.97. What is the ratio of the Female students (as % of total students) of Primary education in 1994 to that in 1996?
Keep it short and to the point. 1. What is the ratio of the Female students (as % of total students) in Tertiary education in 1994 to that in 1996?
Provide a short and direct response. 0.97. What is the ratio of the Female students (as % of total students) in Secondary general education in 1994 to that in 1996?
Your answer should be compact. 0.99. What is the ratio of the Female students (as % of total students) of Secondary vocational education in 1994 to that in 1996?
Offer a terse response. 0.87. What is the ratio of the Female students (as % of total students) in Tertiary education in 1994 to that in 1997?
Keep it short and to the point. 0.97. What is the ratio of the Female students (as % of total students) of Secondary vocational education in 1994 to that in 1997?
Ensure brevity in your answer.  0.87. What is the ratio of the Female students (as % of total students) of Primary education in 1995 to that in 1996?
Offer a terse response. 1.01. What is the ratio of the Female students (as % of total students) of Tertiary education in 1995 to that in 1996?
Offer a terse response. 1. What is the ratio of the Female students (as % of total students) of Secondary vocational education in 1995 to that in 1996?
Your response must be concise. 0.9. What is the ratio of the Female students (as % of total students) in Primary education in 1995 to that in 1997?
Ensure brevity in your answer.  1.01. What is the ratio of the Female students (as % of total students) of Secondary general education in 1995 to that in 1997?
Your response must be concise. 1. What is the ratio of the Female students (as % of total students) in Secondary vocational education in 1995 to that in 1997?
Give a very brief answer. 0.89. What is the ratio of the Female students (as % of total students) in Tertiary education in 1996 to that in 1997?
Offer a terse response. 1. What is the ratio of the Female students (as % of total students) in Secondary general education in 1996 to that in 1997?
Provide a short and direct response. 1. What is the ratio of the Female students (as % of total students) of Secondary vocational education in 1996 to that in 1997?
Your answer should be compact. 0.99. What is the difference between the highest and the second highest Female students (as % of total students) in Primary education?
Provide a short and direct response. 0.3. What is the difference between the highest and the second highest Female students (as % of total students) in Tertiary education?
Make the answer very short. 0.17. What is the difference between the highest and the second highest Female students (as % of total students) of Secondary general education?
Provide a short and direct response. 0.11. What is the difference between the highest and the second highest Female students (as % of total students) in Secondary vocational education?
Your response must be concise. 0.26. What is the difference between the highest and the lowest Female students (as % of total students) in Primary education?
Your answer should be compact. 0.4. What is the difference between the highest and the lowest Female students (as % of total students) in Tertiary education?
Offer a very short reply. 1.59. What is the difference between the highest and the lowest Female students (as % of total students) of Secondary general education?
Keep it short and to the point. 1.15. What is the difference between the highest and the lowest Female students (as % of total students) in Secondary vocational education?
Make the answer very short. 6.97. 